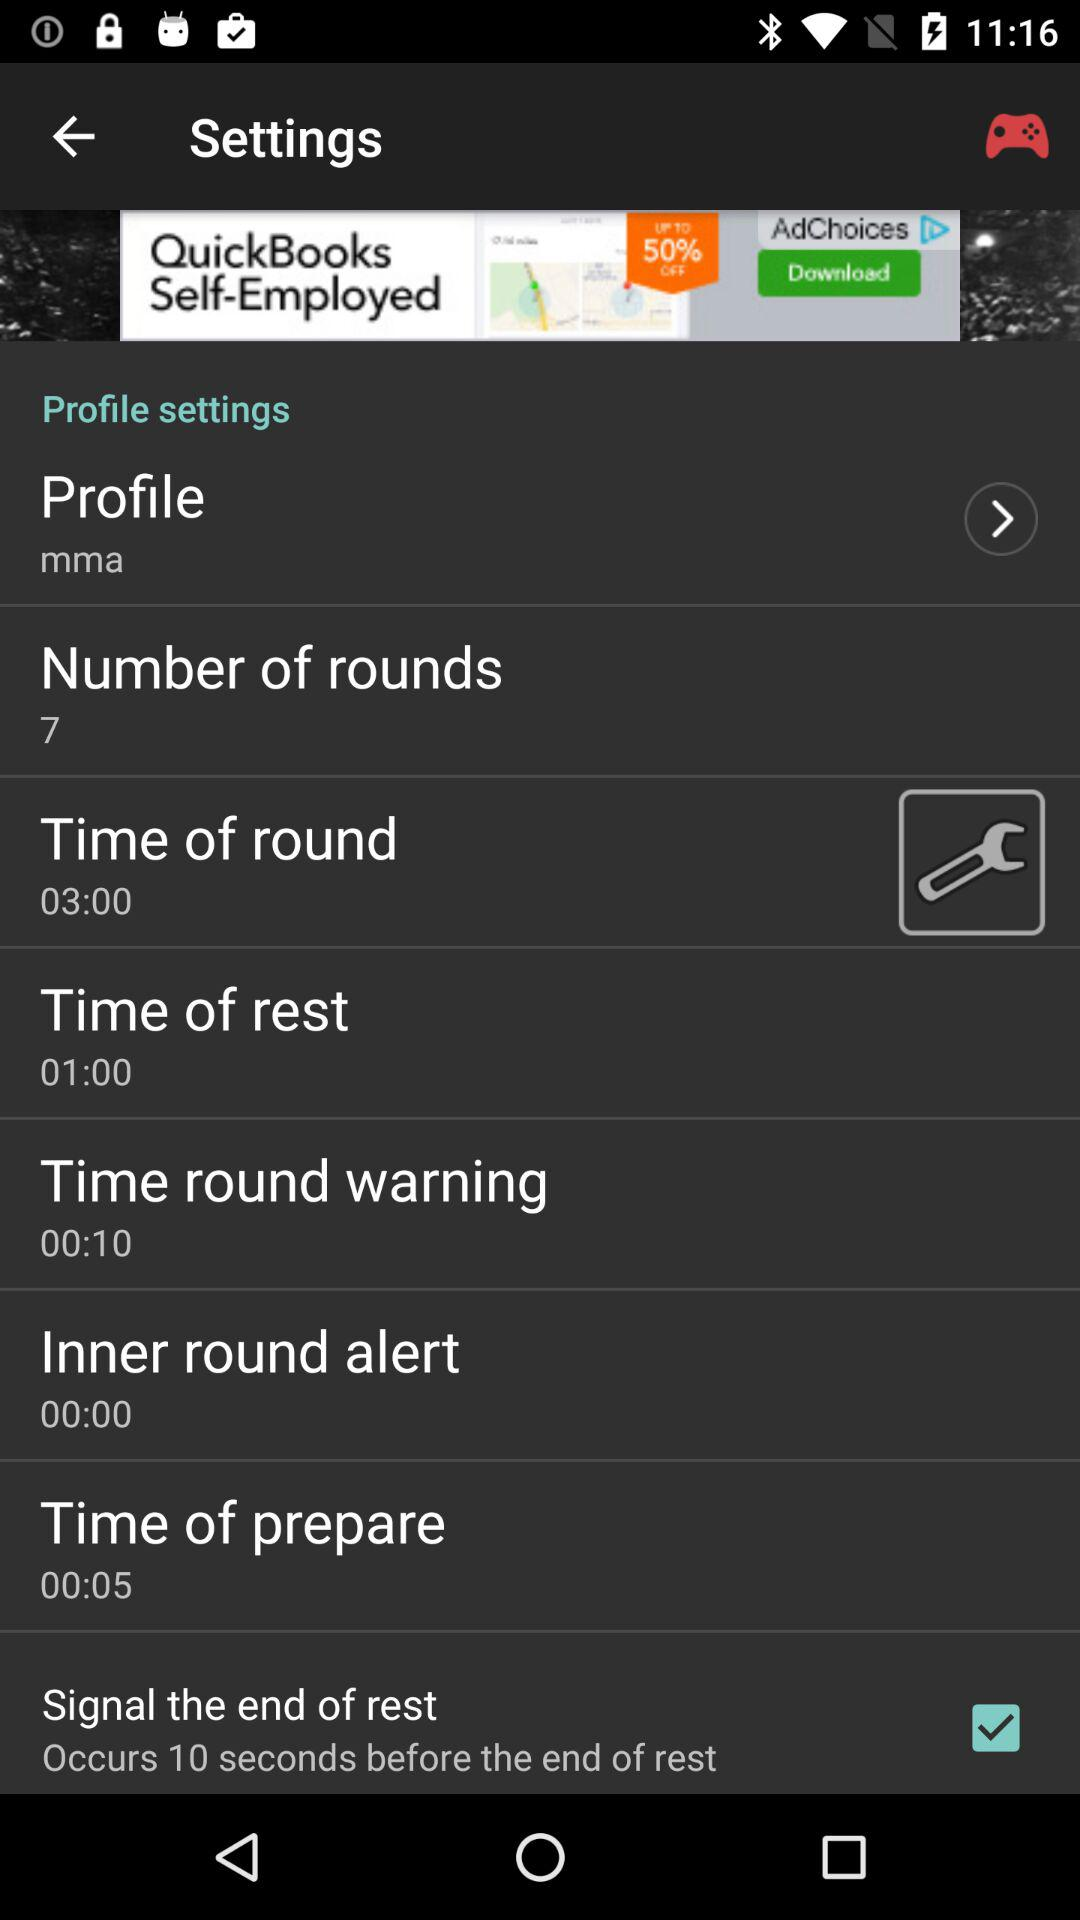What is the duration of the time of rest? The duration is 01:00. 